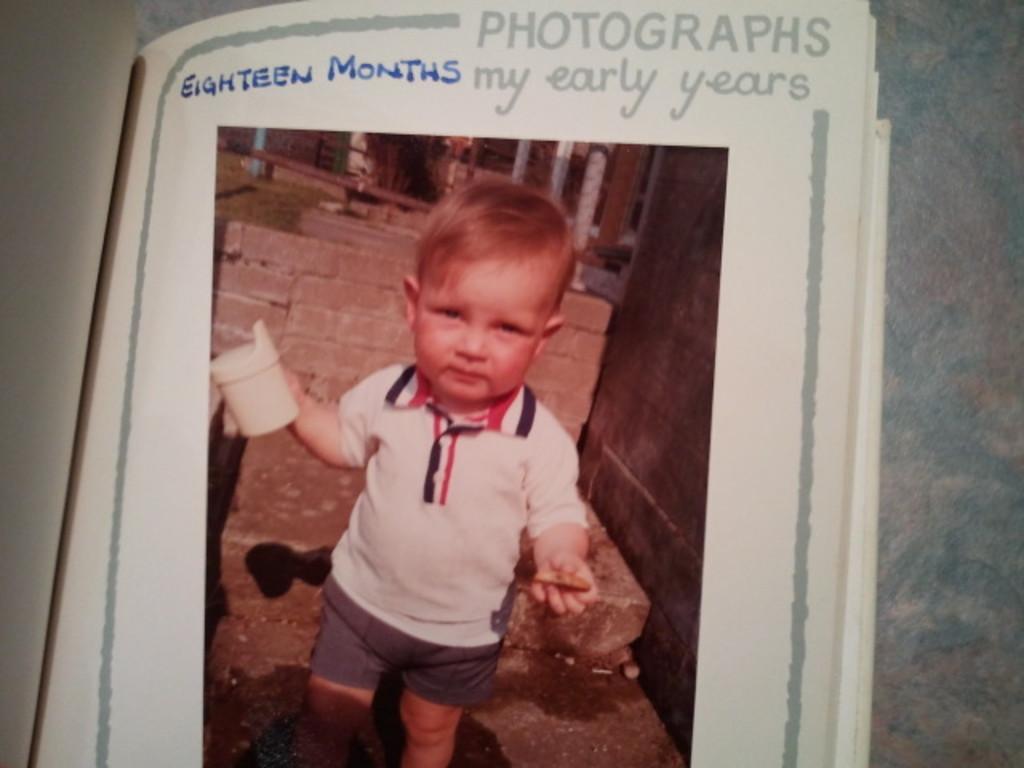Could you give a brief overview of what you see in this image? In this picture we can see a book, in the book we can find a boy and some text, he is holding an object. 